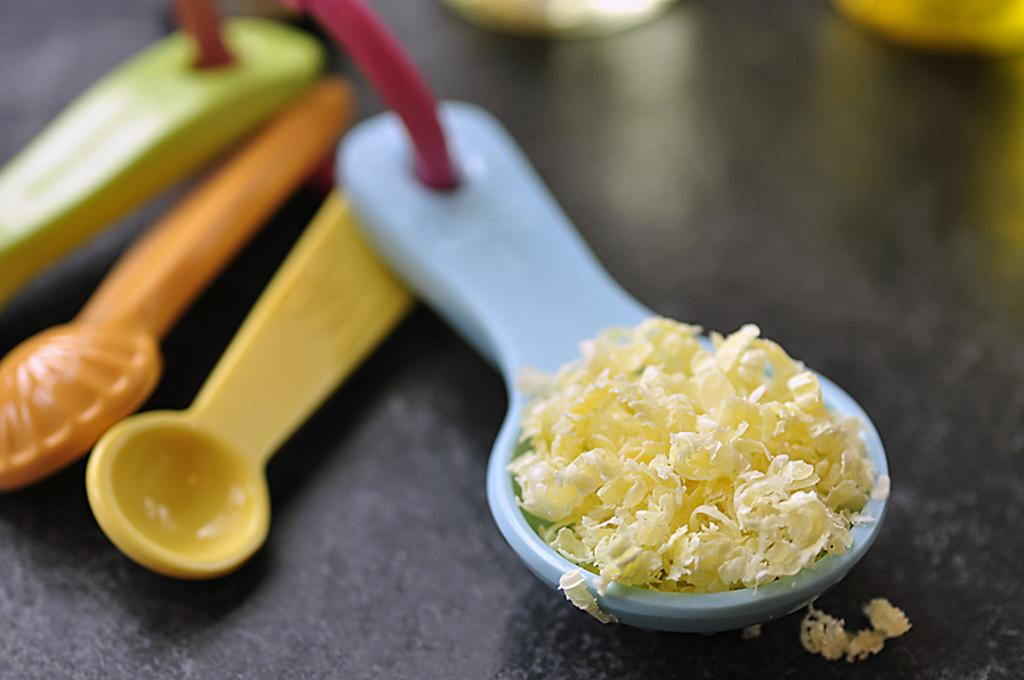What is present on the spoon in the image? There is food in a spoon in the image. What can be observed about the spoons on the floor? There are different colored spoons on the floor. Can you tell me how many dogs are sitting on the dock in the image? There is no dock or dog present in the image; it only features a spoon with food and different colored spoons on the floor. 